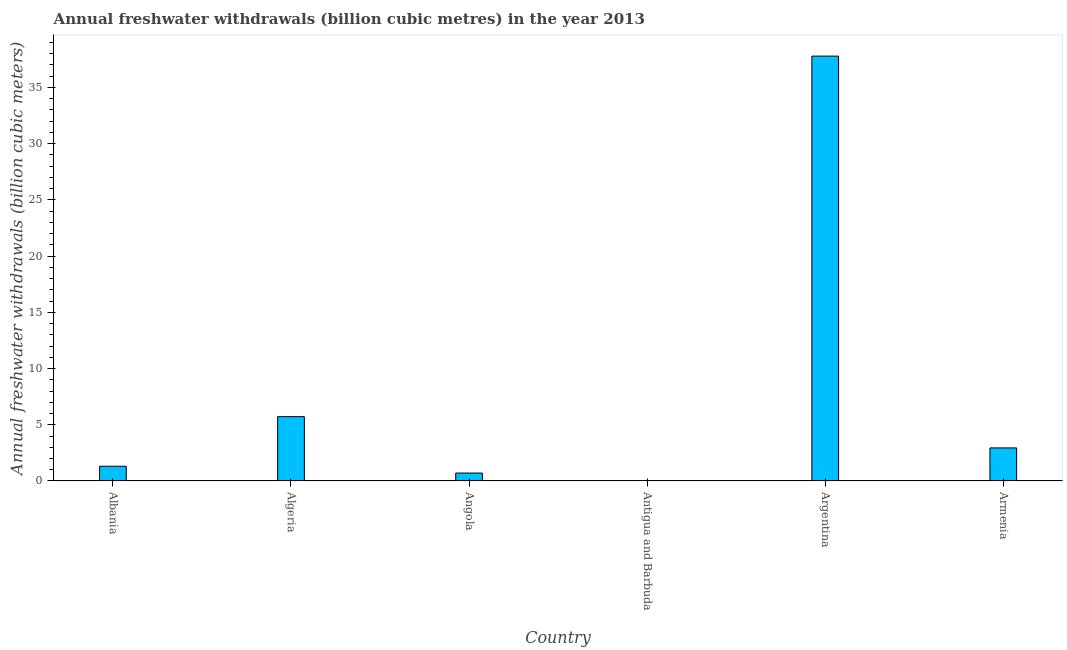Does the graph contain grids?
Your answer should be compact. No. What is the title of the graph?
Provide a succinct answer. Annual freshwater withdrawals (billion cubic metres) in the year 2013. What is the label or title of the X-axis?
Make the answer very short. Country. What is the label or title of the Y-axis?
Make the answer very short. Annual freshwater withdrawals (billion cubic meters). What is the annual freshwater withdrawals in Angola?
Offer a terse response. 0.71. Across all countries, what is the maximum annual freshwater withdrawals?
Offer a very short reply. 37.78. Across all countries, what is the minimum annual freshwater withdrawals?
Provide a succinct answer. 0.01. In which country was the annual freshwater withdrawals minimum?
Ensure brevity in your answer.  Antigua and Barbuda. What is the sum of the annual freshwater withdrawals?
Your answer should be compact. 48.47. What is the difference between the annual freshwater withdrawals in Albania and Argentina?
Keep it short and to the point. -36.47. What is the average annual freshwater withdrawals per country?
Your answer should be very brief. 8.08. What is the median annual freshwater withdrawals?
Provide a short and direct response. 2.13. In how many countries, is the annual freshwater withdrawals greater than 2 billion cubic meters?
Your answer should be very brief. 3. What is the ratio of the annual freshwater withdrawals in Albania to that in Angola?
Provide a succinct answer. 1.86. Is the annual freshwater withdrawals in Albania less than that in Algeria?
Your answer should be very brief. Yes. Is the difference between the annual freshwater withdrawals in Albania and Argentina greater than the difference between any two countries?
Your response must be concise. No. What is the difference between the highest and the second highest annual freshwater withdrawals?
Provide a succinct answer. 32.06. Is the sum of the annual freshwater withdrawals in Algeria and Antigua and Barbuda greater than the maximum annual freshwater withdrawals across all countries?
Keep it short and to the point. No. What is the difference between the highest and the lowest annual freshwater withdrawals?
Offer a very short reply. 37.77. Are the values on the major ticks of Y-axis written in scientific E-notation?
Ensure brevity in your answer.  No. What is the Annual freshwater withdrawals (billion cubic meters) in Albania?
Offer a terse response. 1.31. What is the Annual freshwater withdrawals (billion cubic meters) in Algeria?
Your answer should be very brief. 5.72. What is the Annual freshwater withdrawals (billion cubic meters) of Angola?
Offer a very short reply. 0.71. What is the Annual freshwater withdrawals (billion cubic meters) in Antigua and Barbuda?
Your answer should be compact. 0.01. What is the Annual freshwater withdrawals (billion cubic meters) of Argentina?
Ensure brevity in your answer.  37.78. What is the Annual freshwater withdrawals (billion cubic meters) in Armenia?
Provide a short and direct response. 2.94. What is the difference between the Annual freshwater withdrawals (billion cubic meters) in Albania and Algeria?
Give a very brief answer. -4.41. What is the difference between the Annual freshwater withdrawals (billion cubic meters) in Albania and Angola?
Keep it short and to the point. 0.61. What is the difference between the Annual freshwater withdrawals (billion cubic meters) in Albania and Antigua and Barbuda?
Provide a short and direct response. 1.3. What is the difference between the Annual freshwater withdrawals (billion cubic meters) in Albania and Argentina?
Provide a short and direct response. -36.47. What is the difference between the Annual freshwater withdrawals (billion cubic meters) in Albania and Armenia?
Keep it short and to the point. -1.63. What is the difference between the Annual freshwater withdrawals (billion cubic meters) in Algeria and Angola?
Provide a short and direct response. 5.02. What is the difference between the Annual freshwater withdrawals (billion cubic meters) in Algeria and Antigua and Barbuda?
Make the answer very short. 5.71. What is the difference between the Annual freshwater withdrawals (billion cubic meters) in Algeria and Argentina?
Offer a terse response. -32.06. What is the difference between the Annual freshwater withdrawals (billion cubic meters) in Algeria and Armenia?
Make the answer very short. 2.78. What is the difference between the Annual freshwater withdrawals (billion cubic meters) in Angola and Antigua and Barbuda?
Your response must be concise. 0.7. What is the difference between the Annual freshwater withdrawals (billion cubic meters) in Angola and Argentina?
Your answer should be compact. -37.07. What is the difference between the Annual freshwater withdrawals (billion cubic meters) in Angola and Armenia?
Provide a succinct answer. -2.24. What is the difference between the Annual freshwater withdrawals (billion cubic meters) in Antigua and Barbuda and Argentina?
Your answer should be very brief. -37.77. What is the difference between the Annual freshwater withdrawals (billion cubic meters) in Antigua and Barbuda and Armenia?
Give a very brief answer. -2.93. What is the difference between the Annual freshwater withdrawals (billion cubic meters) in Argentina and Armenia?
Provide a short and direct response. 34.84. What is the ratio of the Annual freshwater withdrawals (billion cubic meters) in Albania to that in Algeria?
Your answer should be very brief. 0.23. What is the ratio of the Annual freshwater withdrawals (billion cubic meters) in Albania to that in Angola?
Give a very brief answer. 1.86. What is the ratio of the Annual freshwater withdrawals (billion cubic meters) in Albania to that in Antigua and Barbuda?
Provide a short and direct response. 156.07. What is the ratio of the Annual freshwater withdrawals (billion cubic meters) in Albania to that in Argentina?
Your answer should be compact. 0.04. What is the ratio of the Annual freshwater withdrawals (billion cubic meters) in Albania to that in Armenia?
Ensure brevity in your answer.  0.45. What is the ratio of the Annual freshwater withdrawals (billion cubic meters) in Algeria to that in Angola?
Offer a very short reply. 8.11. What is the ratio of the Annual freshwater withdrawals (billion cubic meters) in Algeria to that in Antigua and Barbuda?
Keep it short and to the point. 681.31. What is the ratio of the Annual freshwater withdrawals (billion cubic meters) in Algeria to that in Argentina?
Make the answer very short. 0.15. What is the ratio of the Annual freshwater withdrawals (billion cubic meters) in Algeria to that in Armenia?
Your answer should be very brief. 1.95. What is the ratio of the Annual freshwater withdrawals (billion cubic meters) in Angola to that in Antigua and Barbuda?
Provide a short and direct response. 84.02. What is the ratio of the Annual freshwater withdrawals (billion cubic meters) in Angola to that in Argentina?
Provide a succinct answer. 0.02. What is the ratio of the Annual freshwater withdrawals (billion cubic meters) in Angola to that in Armenia?
Your response must be concise. 0.24. What is the ratio of the Annual freshwater withdrawals (billion cubic meters) in Antigua and Barbuda to that in Armenia?
Ensure brevity in your answer.  0. What is the ratio of the Annual freshwater withdrawals (billion cubic meters) in Argentina to that in Armenia?
Provide a succinct answer. 12.85. 